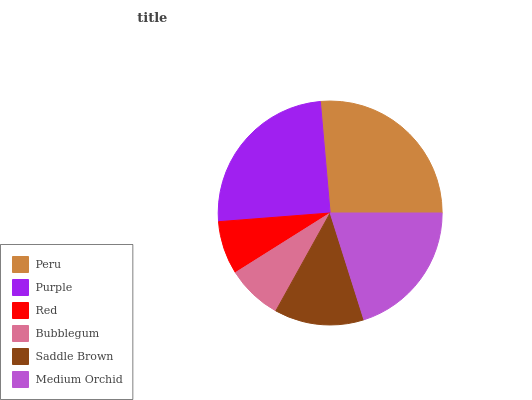Is Red the minimum?
Answer yes or no. Yes. Is Peru the maximum?
Answer yes or no. Yes. Is Purple the minimum?
Answer yes or no. No. Is Purple the maximum?
Answer yes or no. No. Is Peru greater than Purple?
Answer yes or no. Yes. Is Purple less than Peru?
Answer yes or no. Yes. Is Purple greater than Peru?
Answer yes or no. No. Is Peru less than Purple?
Answer yes or no. No. Is Medium Orchid the high median?
Answer yes or no. Yes. Is Saddle Brown the low median?
Answer yes or no. Yes. Is Bubblegum the high median?
Answer yes or no. No. Is Peru the low median?
Answer yes or no. No. 